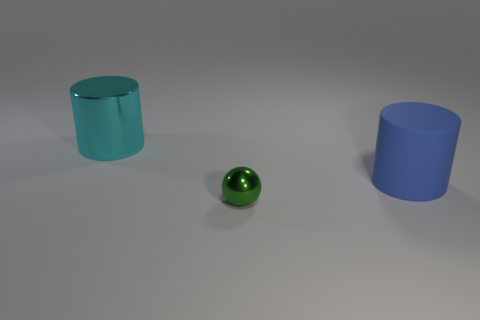Are there fewer big cyan metallic cylinders that are in front of the cyan shiny cylinder than large cyan metal things?
Keep it short and to the point. Yes. What number of blue cylinders are the same size as the cyan thing?
Offer a terse response. 1. What shape is the large thing to the left of the thing that is in front of the large cylinder right of the big metal thing?
Provide a short and direct response. Cylinder. There is a metal object behind the tiny green ball; what is its color?
Give a very brief answer. Cyan. What number of things are things that are right of the tiny green metal object or shiny things that are behind the tiny thing?
Make the answer very short. 2. How many other big rubber things are the same shape as the cyan object?
Offer a very short reply. 1. What is the color of the rubber object that is the same size as the metallic cylinder?
Offer a terse response. Blue. There is a object behind the large thing to the right of the big cylinder that is to the left of the large matte cylinder; what is its color?
Ensure brevity in your answer.  Cyan. Is the size of the sphere the same as the cylinder in front of the cyan shiny cylinder?
Make the answer very short. No. How many objects are gray matte balls or cylinders?
Provide a short and direct response. 2. 